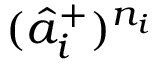<formula> <loc_0><loc_0><loc_500><loc_500>( \hat { a } _ { i } ^ { + } ) ^ { n _ { i } }</formula> 